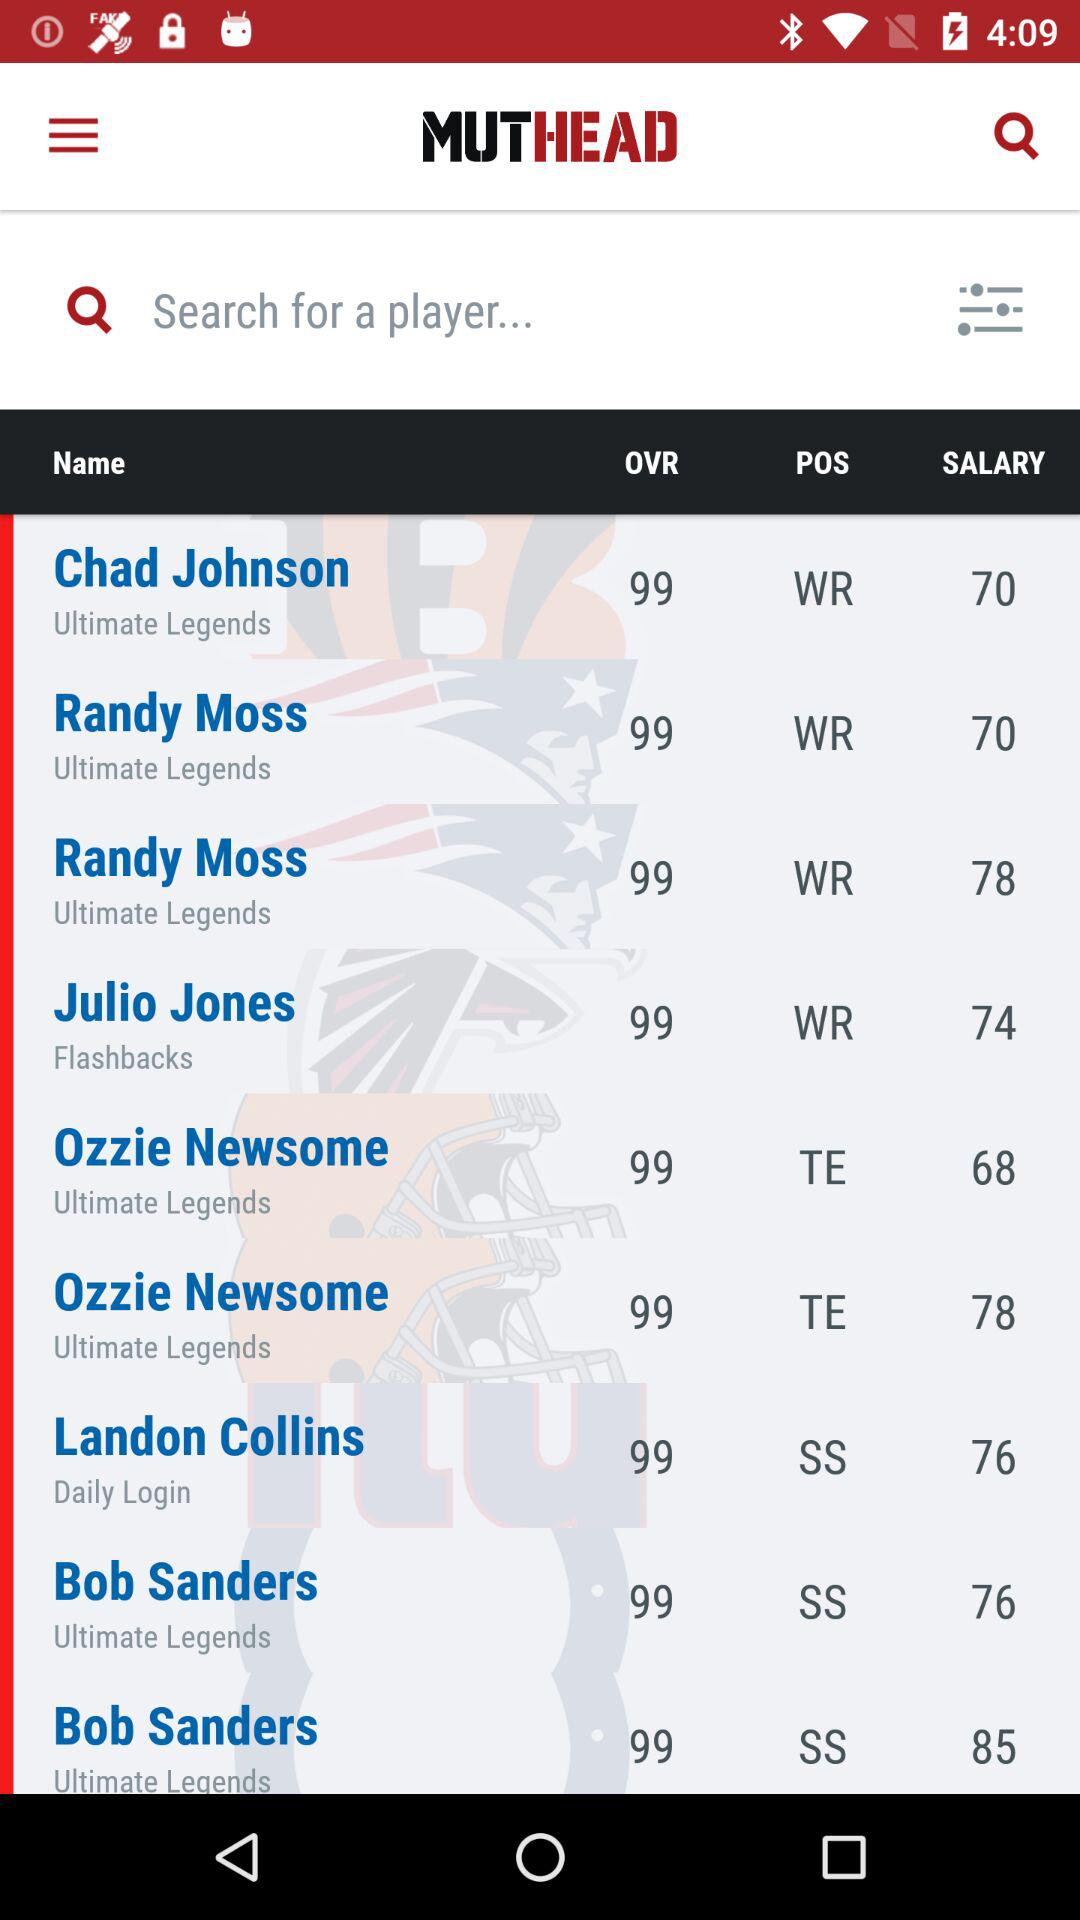What position does Julio Jones occupy? Julio Jones occupies the WR position. 